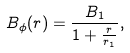<formula> <loc_0><loc_0><loc_500><loc_500>B _ { \phi } ( r ) = \frac { B _ { 1 } } { 1 + \frac { r } { r _ { 1 } } } ,</formula> 